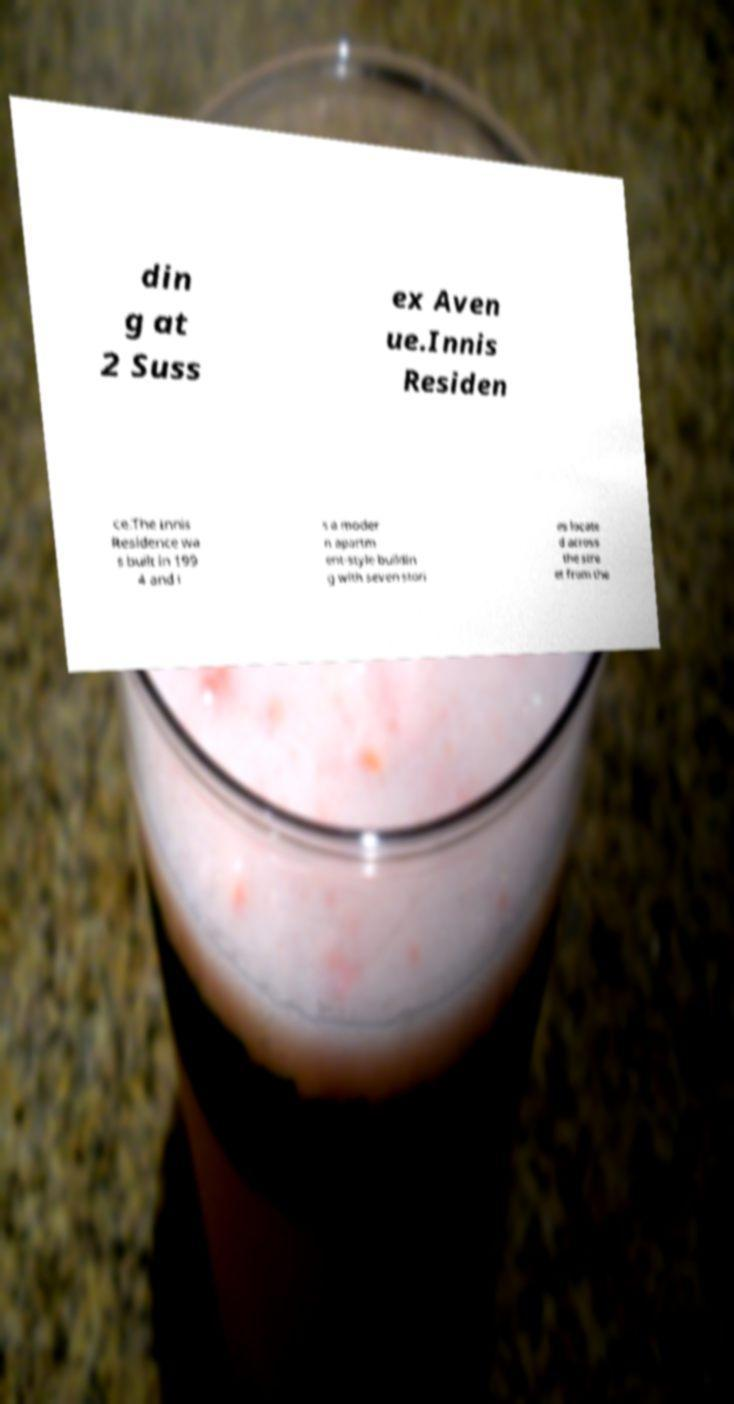Please read and relay the text visible in this image. What does it say? din g at 2 Suss ex Aven ue.Innis Residen ce.The Innis Residence wa s built in 199 4 and i s a moder n apartm ent-style buildin g with seven stori es locate d across the stre et from the 